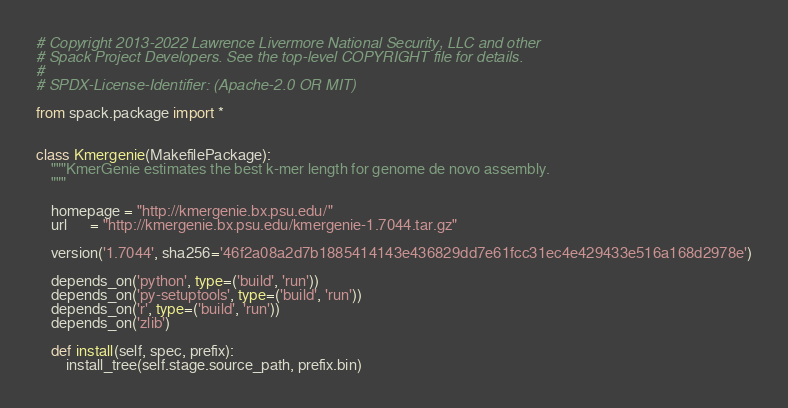Convert code to text. <code><loc_0><loc_0><loc_500><loc_500><_Python_># Copyright 2013-2022 Lawrence Livermore National Security, LLC and other
# Spack Project Developers. See the top-level COPYRIGHT file for details.
#
# SPDX-License-Identifier: (Apache-2.0 OR MIT)

from spack.package import *


class Kmergenie(MakefilePackage):
    """KmerGenie estimates the best k-mer length for genome de novo assembly.
    """

    homepage = "http://kmergenie.bx.psu.edu/"
    url      = "http://kmergenie.bx.psu.edu/kmergenie-1.7044.tar.gz"

    version('1.7044', sha256='46f2a08a2d7b1885414143e436829dd7e61fcc31ec4e429433e516a168d2978e')

    depends_on('python', type=('build', 'run'))
    depends_on('py-setuptools', type=('build', 'run'))
    depends_on('r', type=('build', 'run'))
    depends_on('zlib')

    def install(self, spec, prefix):
        install_tree(self.stage.source_path, prefix.bin)
</code> 